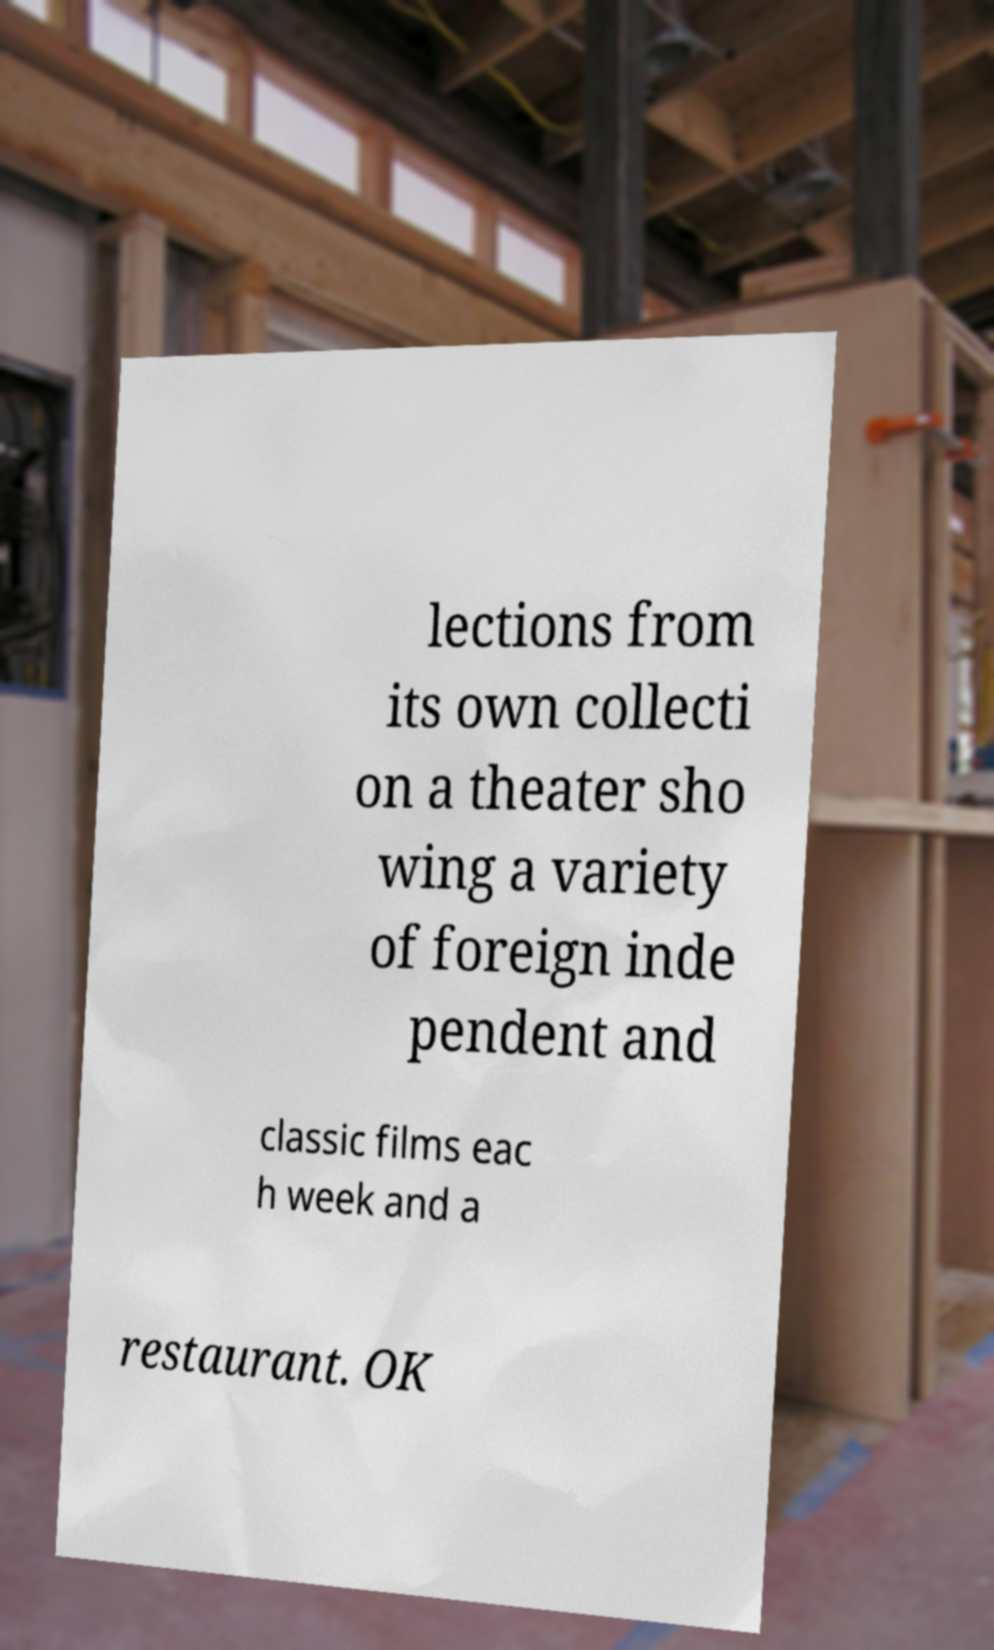What messages or text are displayed in this image? I need them in a readable, typed format. lections from its own collecti on a theater sho wing a variety of foreign inde pendent and classic films eac h week and a restaurant. OK 